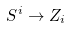Convert formula to latex. <formula><loc_0><loc_0><loc_500><loc_500>S ^ { i } \to Z _ { i }</formula> 